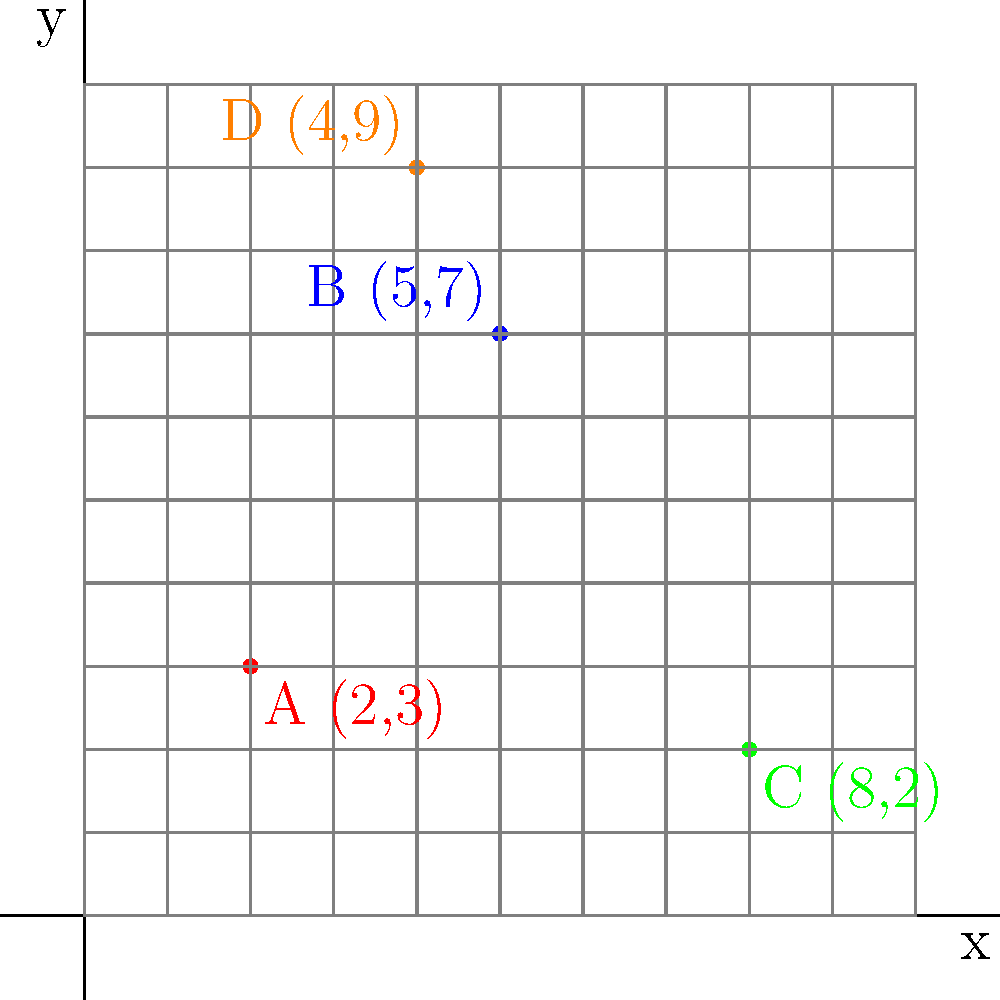As a boxing event organizer in San Salvador, you're planning a series of matches across the city. You've plotted four potential venues on a coordinate grid representing the city map. Venue A is at (2,3), Venue B at (5,7), Venue C at (8,2), and Venue D at (4,9). If you want to minimize travel time between venues, which two venues should host back-to-back events? Calculate the distance between them using the distance formula. To solve this problem, we need to follow these steps:

1. Recall the distance formula: $d = \sqrt{(x_2-x_1)^2 + (y_2-y_1)^2}$

2. Calculate the distances between all pairs of venues:

   AB: $d = \sqrt{(5-2)^2 + (7-3)^2} = \sqrt{3^2 + 4^2} = \sqrt{25} = 5$
   AC: $d = \sqrt{(8-2)^2 + (2-3)^2} = \sqrt{6^2 + (-1)^2} = \sqrt{37} \approx 6.08$
   AD: $d = \sqrt{(4-2)^2 + (9-3)^2} = \sqrt{2^2 + 6^2} = \sqrt{40} \approx 6.32$
   BC: $d = \sqrt{(8-5)^2 + (2-7)^2} = \sqrt{3^2 + (-5)^2} = \sqrt{34} \approx 5.83$
   BD: $d = \sqrt{(4-5)^2 + (9-7)^2} = \sqrt{(-1)^2 + 2^2} = \sqrt{5} \approx 2.24$
   CD: $d = \sqrt{(4-8)^2 + (9-2)^2} = \sqrt{(-4)^2 + 7^2} = \sqrt{65} \approx 8.06$

3. The shortest distance is between venues B and D, with a distance of approximately 2.24 units.

Therefore, to minimize travel time, venues B and D should host back-to-back events.
Answer: Venues B and D, distance ≈ 2.24 units 